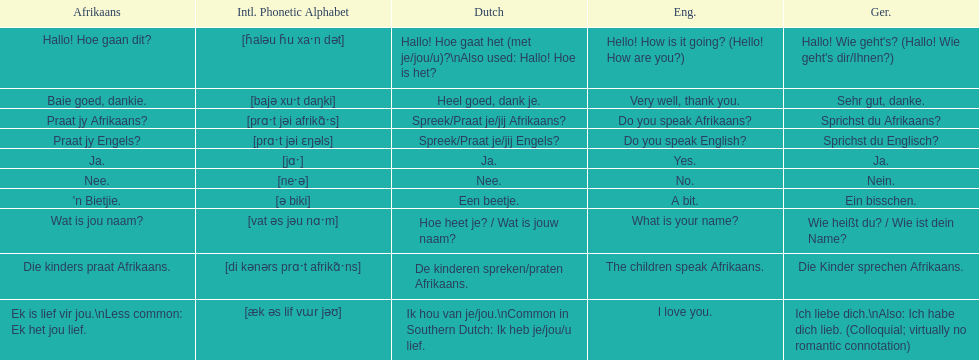Translate the following into english: 'n bietjie. A bit. 